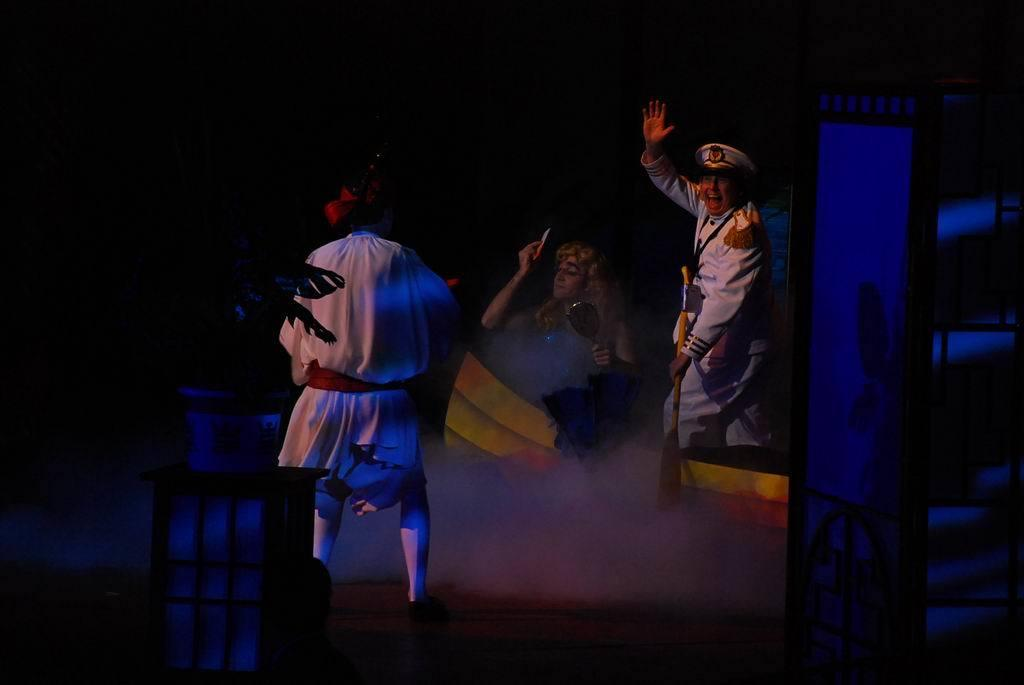What is the person on the right side of the image holding? The person on the right side of the image is holding a wooden object. What is the person on the left side of the image holding? There is no mention of the person on the left side of the image holding anything specific. What is the person in the middle of the image holding? The person in the middle of the image is holding a mirror. What type of trousers is the person on the left side of the image wearing? There is no mention of the person on the left side of the image wearing any specific type of trousers. What kind of music is the band playing in the image? There is no mention of a band or any music being played in the image. 